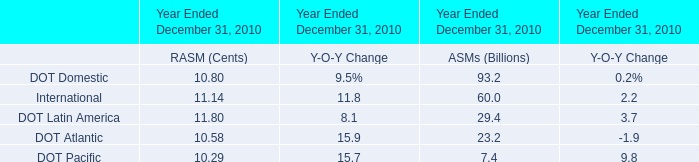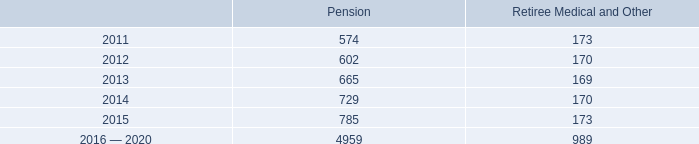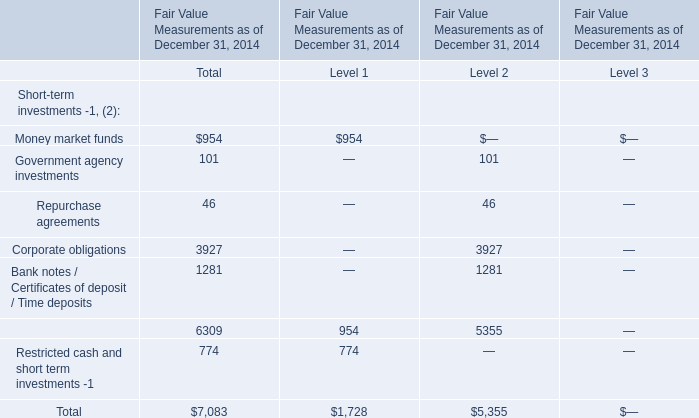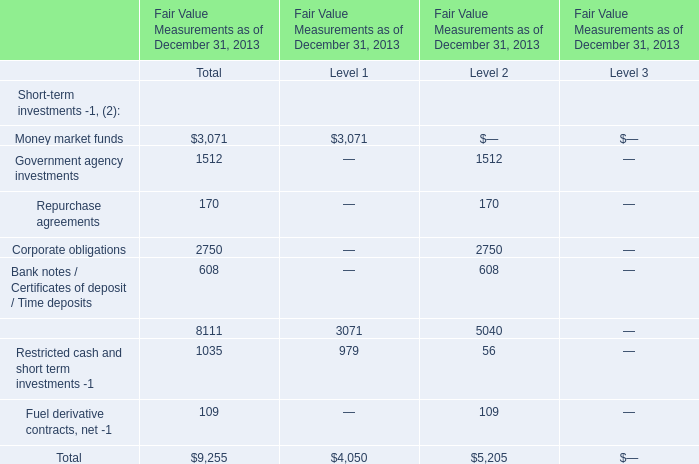What's the sum of all Short-term investments of Total that are greater than 900 in 2014? (in dollars) 
Computations: ((954 + 3927) + 1281)
Answer: 6162.0. 